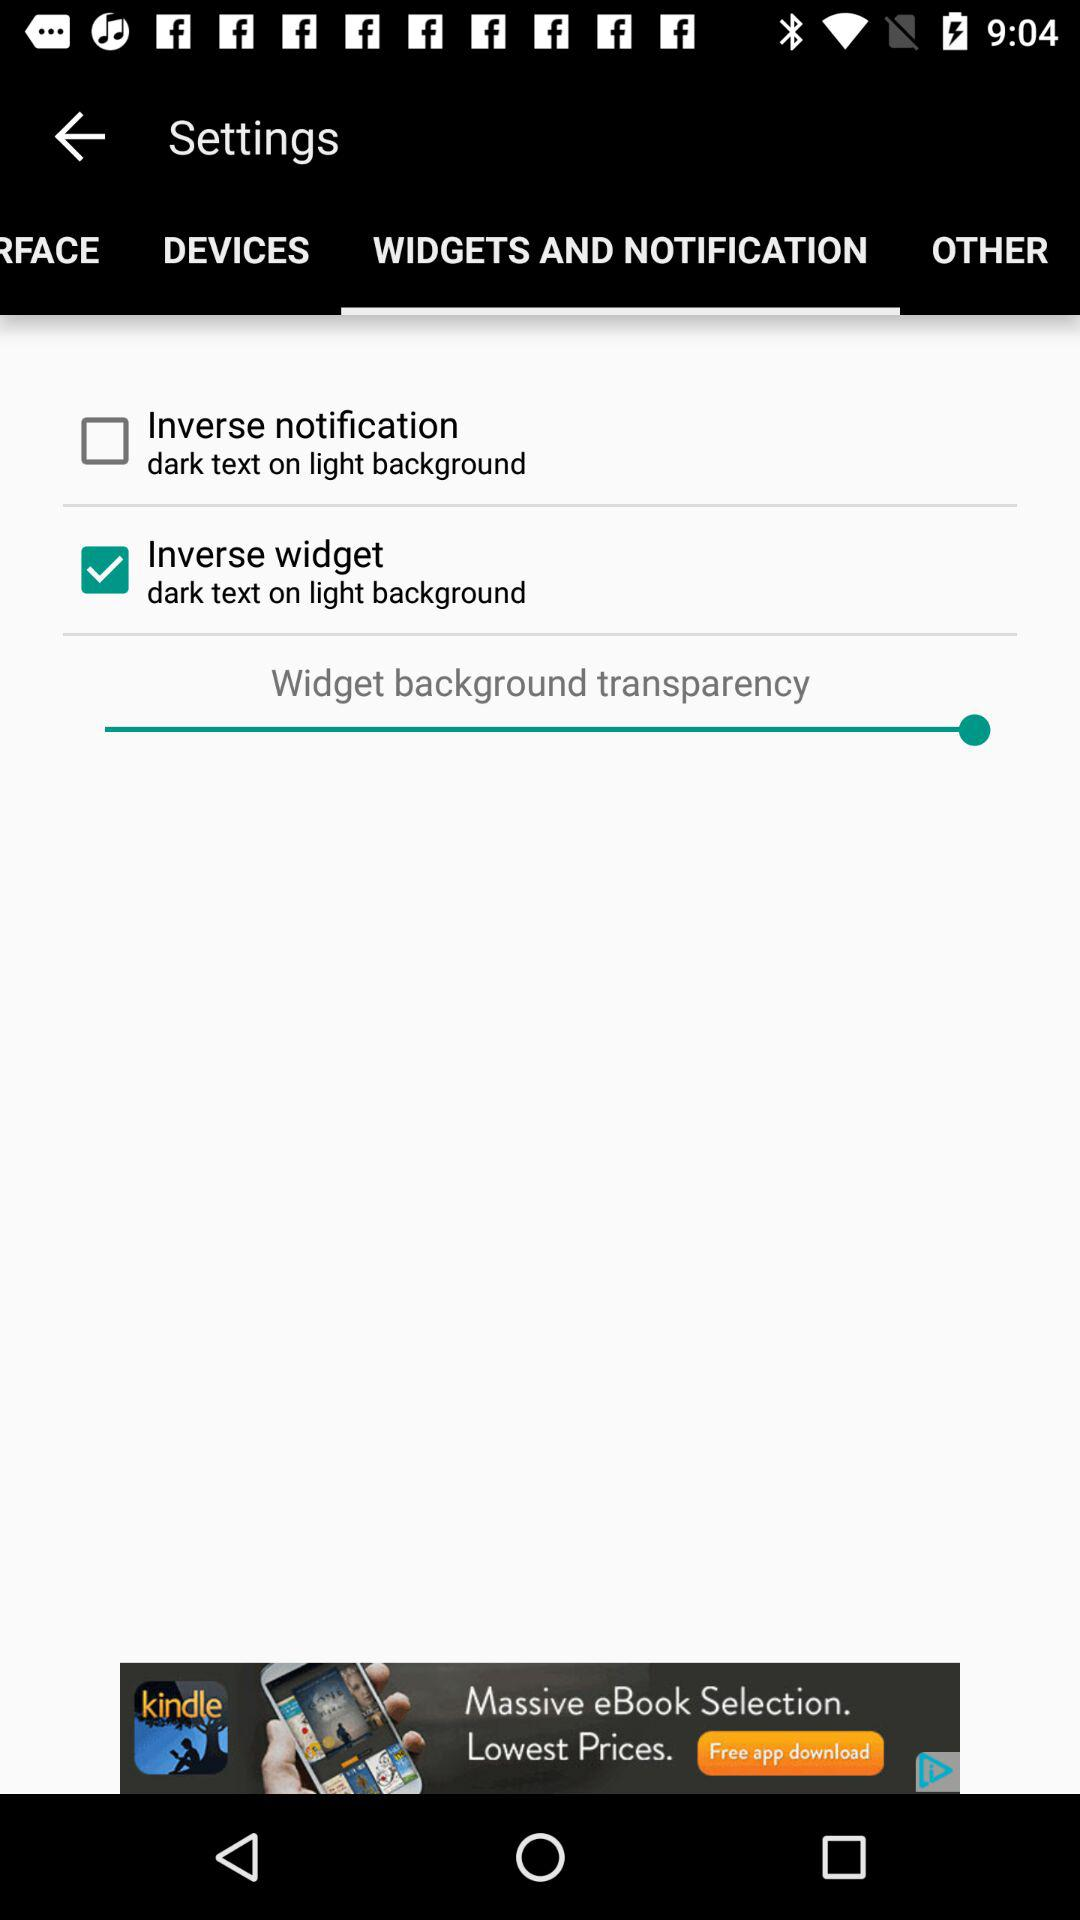What is the status of the "Inverse notification"? The status is "off". 